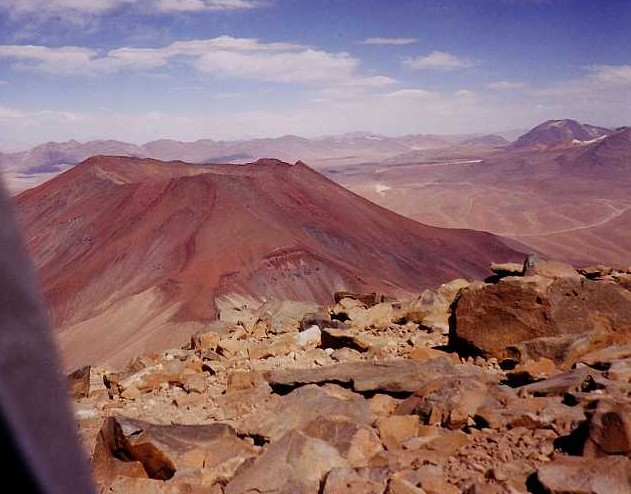What geological processes might have led to the formation of the reddish-brown mountain in the image? The striking reddish-brown hue of the mountain in the image is indicative of iron-rich minerals, such as hematite or iron oxide, which undergo oxidation and rust when exposed to air and water. This results in the distinctive color. The mountain's gently sloping profile suggests it could be a shield volcano, characterized by eruptions of low-viscosity lava that flows over great distances before cooling and solidifying. Alternatively, it may represent sedimentary layers that have been exposed due to erosion over time. Understanding these processes not only helps in studying geological evolution but also in predicting future environmental integration and potential uses in areas like mining or tourism. 